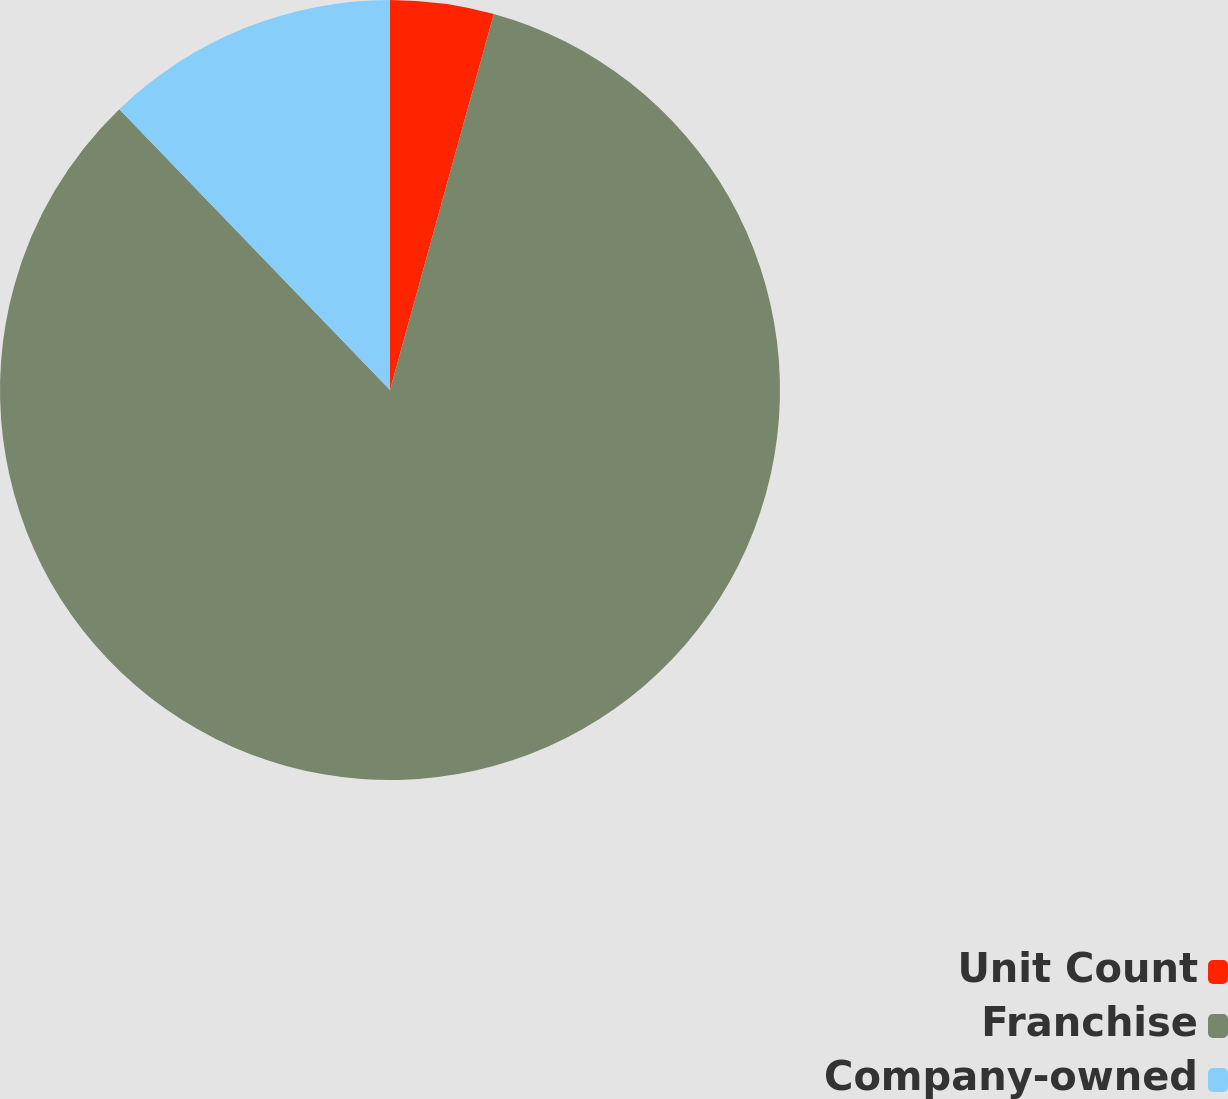Convert chart to OTSL. <chart><loc_0><loc_0><loc_500><loc_500><pie_chart><fcel>Unit Count<fcel>Franchise<fcel>Company-owned<nl><fcel>4.29%<fcel>83.51%<fcel>12.21%<nl></chart> 